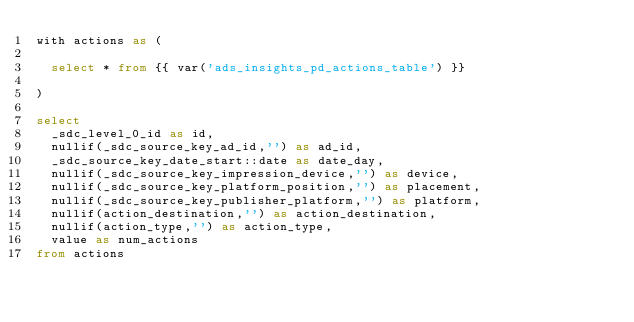<code> <loc_0><loc_0><loc_500><loc_500><_SQL_>with actions as (

  select * from {{ var('ads_insights_pd_actions_table') }}

)

select
  _sdc_level_0_id as id,
  nullif(_sdc_source_key_ad_id,'') as ad_id,
  _sdc_source_key_date_start::date as date_day,
  nullif(_sdc_source_key_impression_device,'') as device,
  nullif(_sdc_source_key_platform_position,'') as placement,
  nullif(_sdc_source_key_publisher_platform,'') as platform,
  nullif(action_destination,'') as action_destination,
  nullif(action_type,'') as action_type,
  value as num_actions
from actions
</code> 